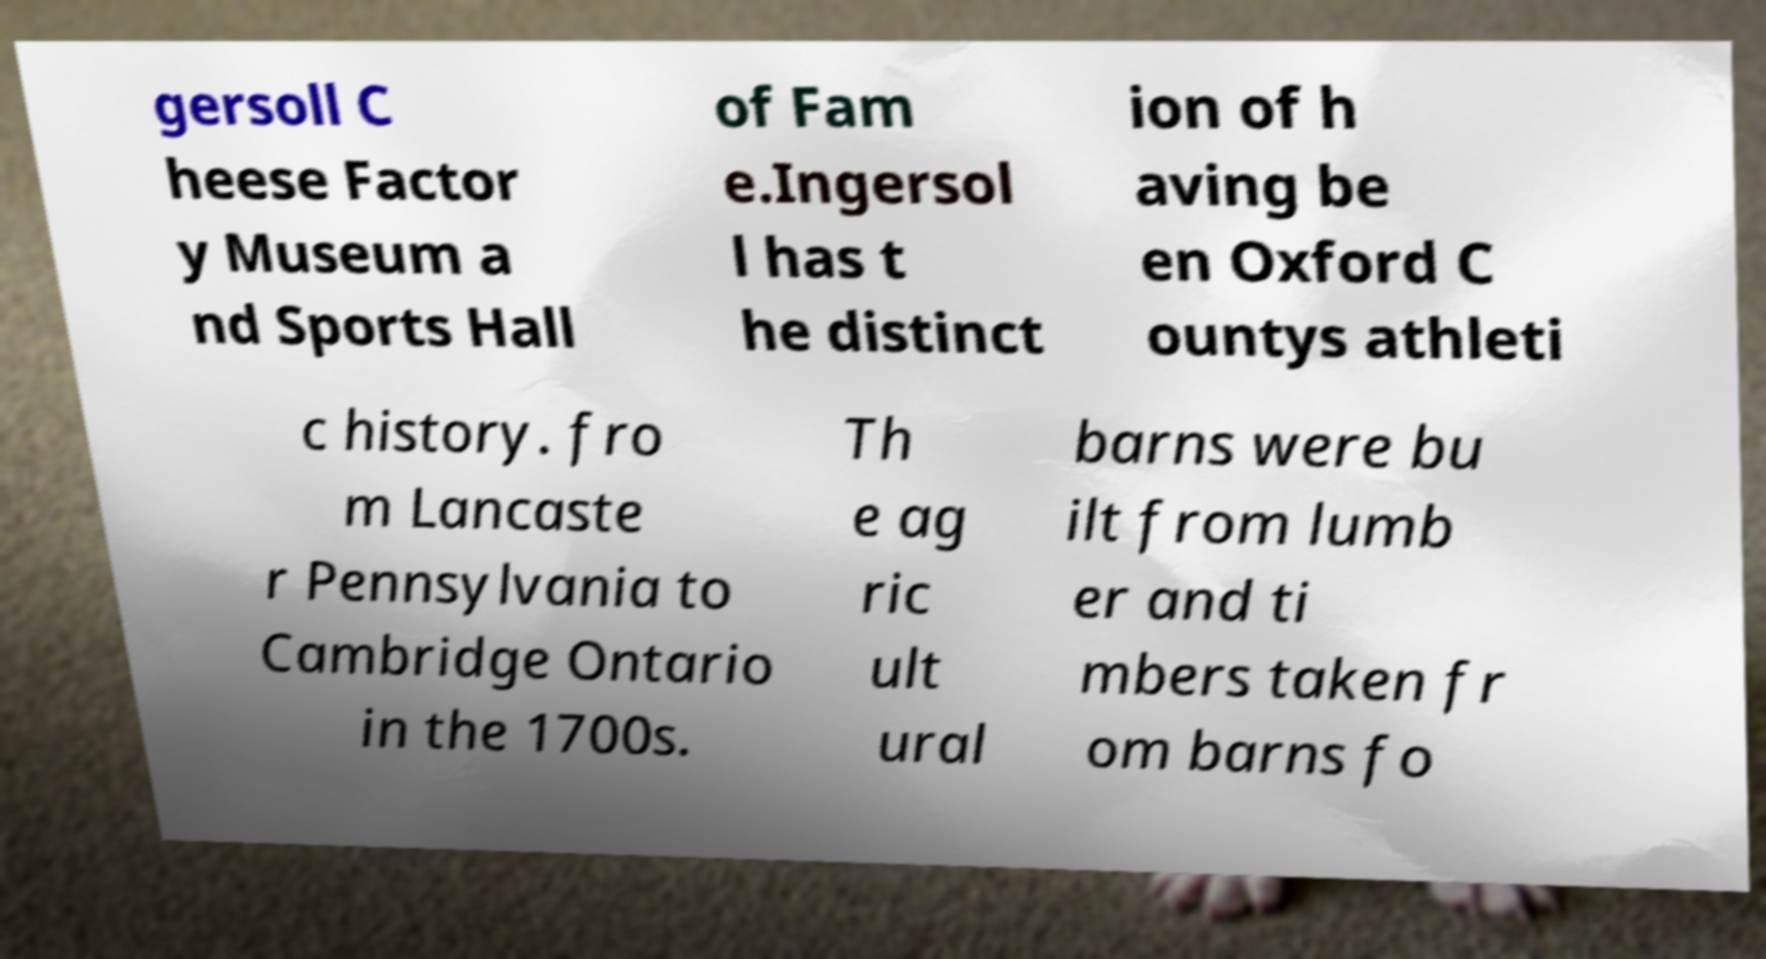Please identify and transcribe the text found in this image. gersoll C heese Factor y Museum a nd Sports Hall of Fam e.Ingersol l has t he distinct ion of h aving be en Oxford C ountys athleti c history. fro m Lancaste r Pennsylvania to Cambridge Ontario in the 1700s. Th e ag ric ult ural barns were bu ilt from lumb er and ti mbers taken fr om barns fo 